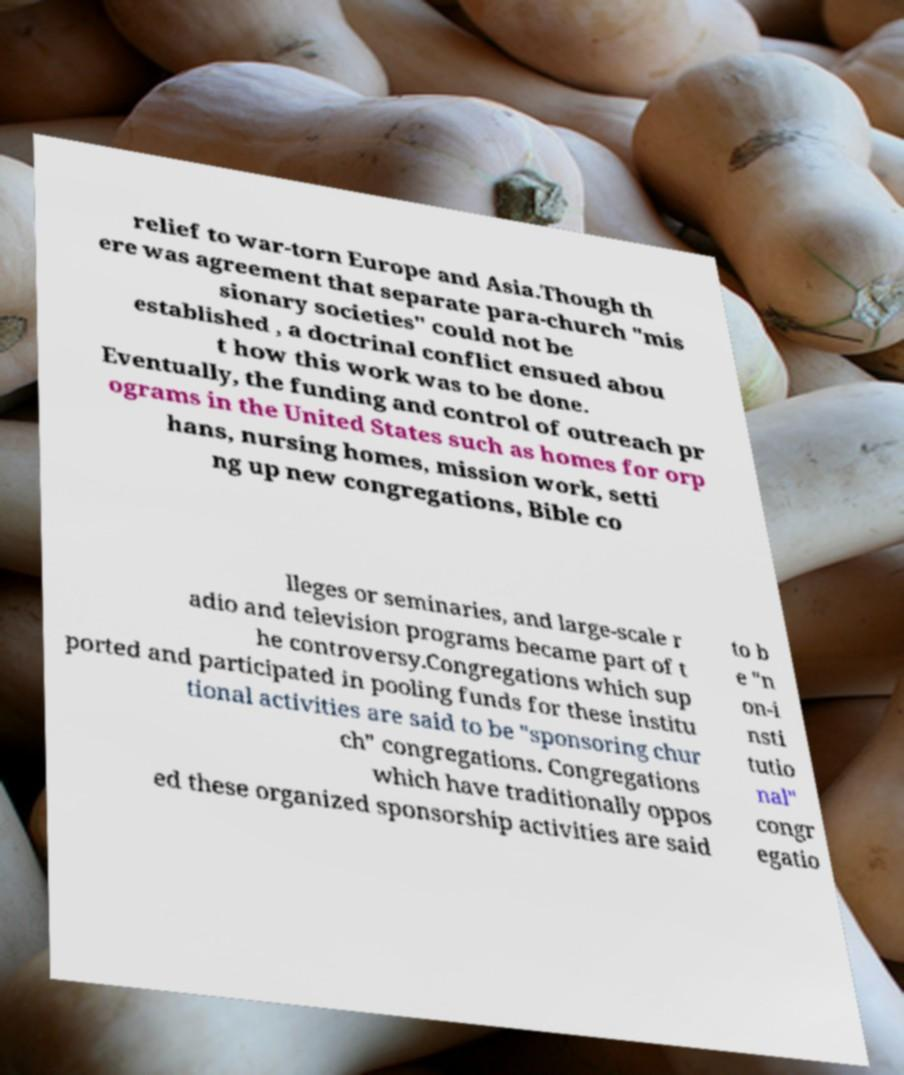Could you extract and type out the text from this image? relief to war-torn Europe and Asia.Though th ere was agreement that separate para-church "mis sionary societies" could not be established , a doctrinal conflict ensued abou t how this work was to be done. Eventually, the funding and control of outreach pr ograms in the United States such as homes for orp hans, nursing homes, mission work, setti ng up new congregations, Bible co lleges or seminaries, and large-scale r adio and television programs became part of t he controversy.Congregations which sup ported and participated in pooling funds for these institu tional activities are said to be "sponsoring chur ch" congregations. Congregations which have traditionally oppos ed these organized sponsorship activities are said to b e "n on-i nsti tutio nal" congr egatio 